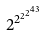<formula> <loc_0><loc_0><loc_500><loc_500>2 ^ { 2 ^ { 2 ^ { 2 ^ { 4 3 } } } }</formula> 